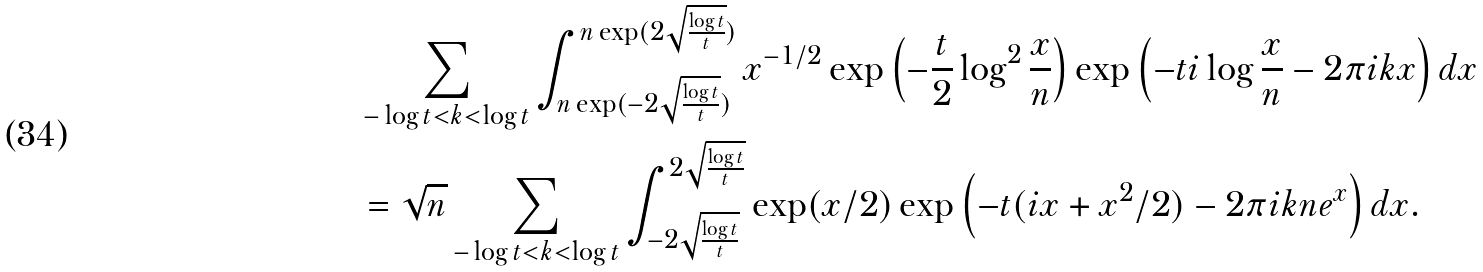Convert formula to latex. <formula><loc_0><loc_0><loc_500><loc_500>& \sum _ { - \log t < k < \log t } \int _ { n \exp ( - 2 \sqrt { \frac { \log t } { t } } ) } ^ { n \exp ( 2 \sqrt { \frac { \log t } { t } } ) } x ^ { - 1 / 2 } \exp \left ( - \frac { t } { 2 } \log ^ { 2 } \frac { x } { n } \right ) \exp \left ( - t i \log \frac { x } { n } - 2 \pi i k x \right ) d x \\ & = \sqrt { n } \sum _ { - \log t < k < \log t } \int _ { - 2 \sqrt { \frac { \log t } { t } } } ^ { 2 \sqrt { \frac { \log t } { t } } } \exp ( x / 2 ) \exp \left ( - t ( i x + x ^ { 2 } / 2 ) - 2 \pi i k n e ^ { x } \right ) d x .</formula> 